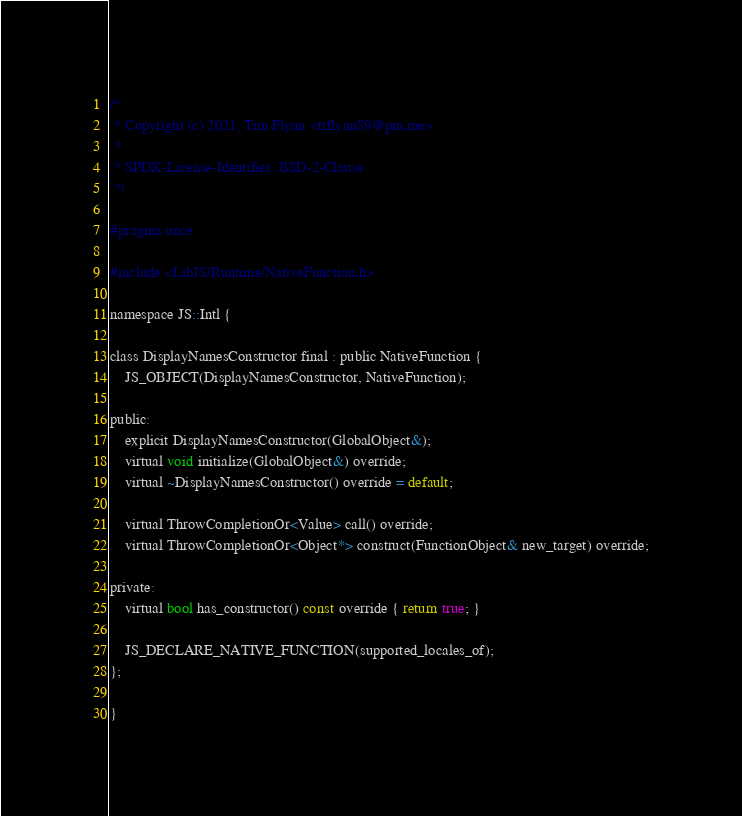<code> <loc_0><loc_0><loc_500><loc_500><_C_>/*
 * Copyright (c) 2021, Tim Flynn <trflynn89@pm.me>
 *
 * SPDX-License-Identifier: BSD-2-Clause
 */

#pragma once

#include <LibJS/Runtime/NativeFunction.h>

namespace JS::Intl {

class DisplayNamesConstructor final : public NativeFunction {
    JS_OBJECT(DisplayNamesConstructor, NativeFunction);

public:
    explicit DisplayNamesConstructor(GlobalObject&);
    virtual void initialize(GlobalObject&) override;
    virtual ~DisplayNamesConstructor() override = default;

    virtual ThrowCompletionOr<Value> call() override;
    virtual ThrowCompletionOr<Object*> construct(FunctionObject& new_target) override;

private:
    virtual bool has_constructor() const override { return true; }

    JS_DECLARE_NATIVE_FUNCTION(supported_locales_of);
};

}
</code> 